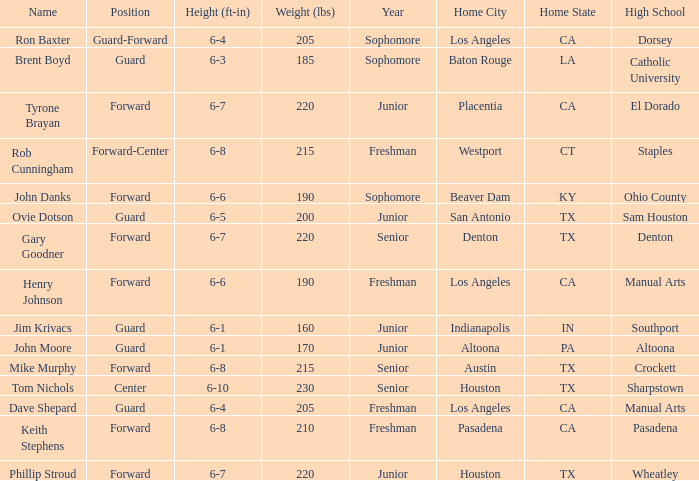What is the Home Town with a Year of freshman, and a Height with 6–6? Los Angeles, CA. 